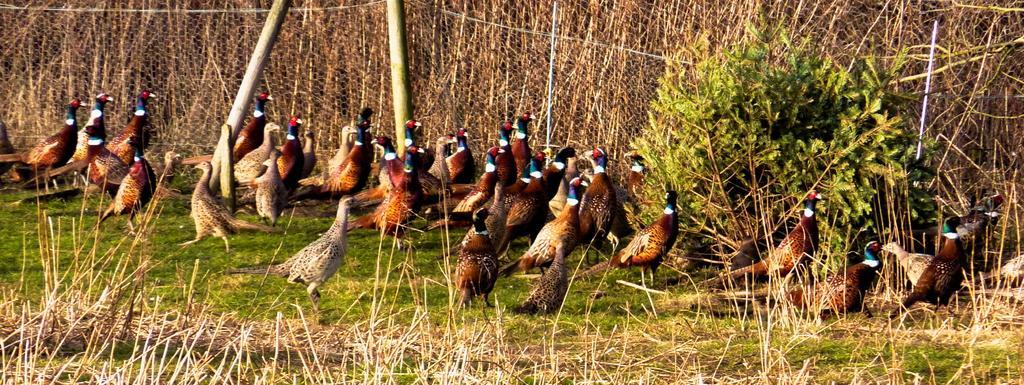Please provide a concise description of this image. In this image there are birds, behind the birds there is fencing, plants and grass. 